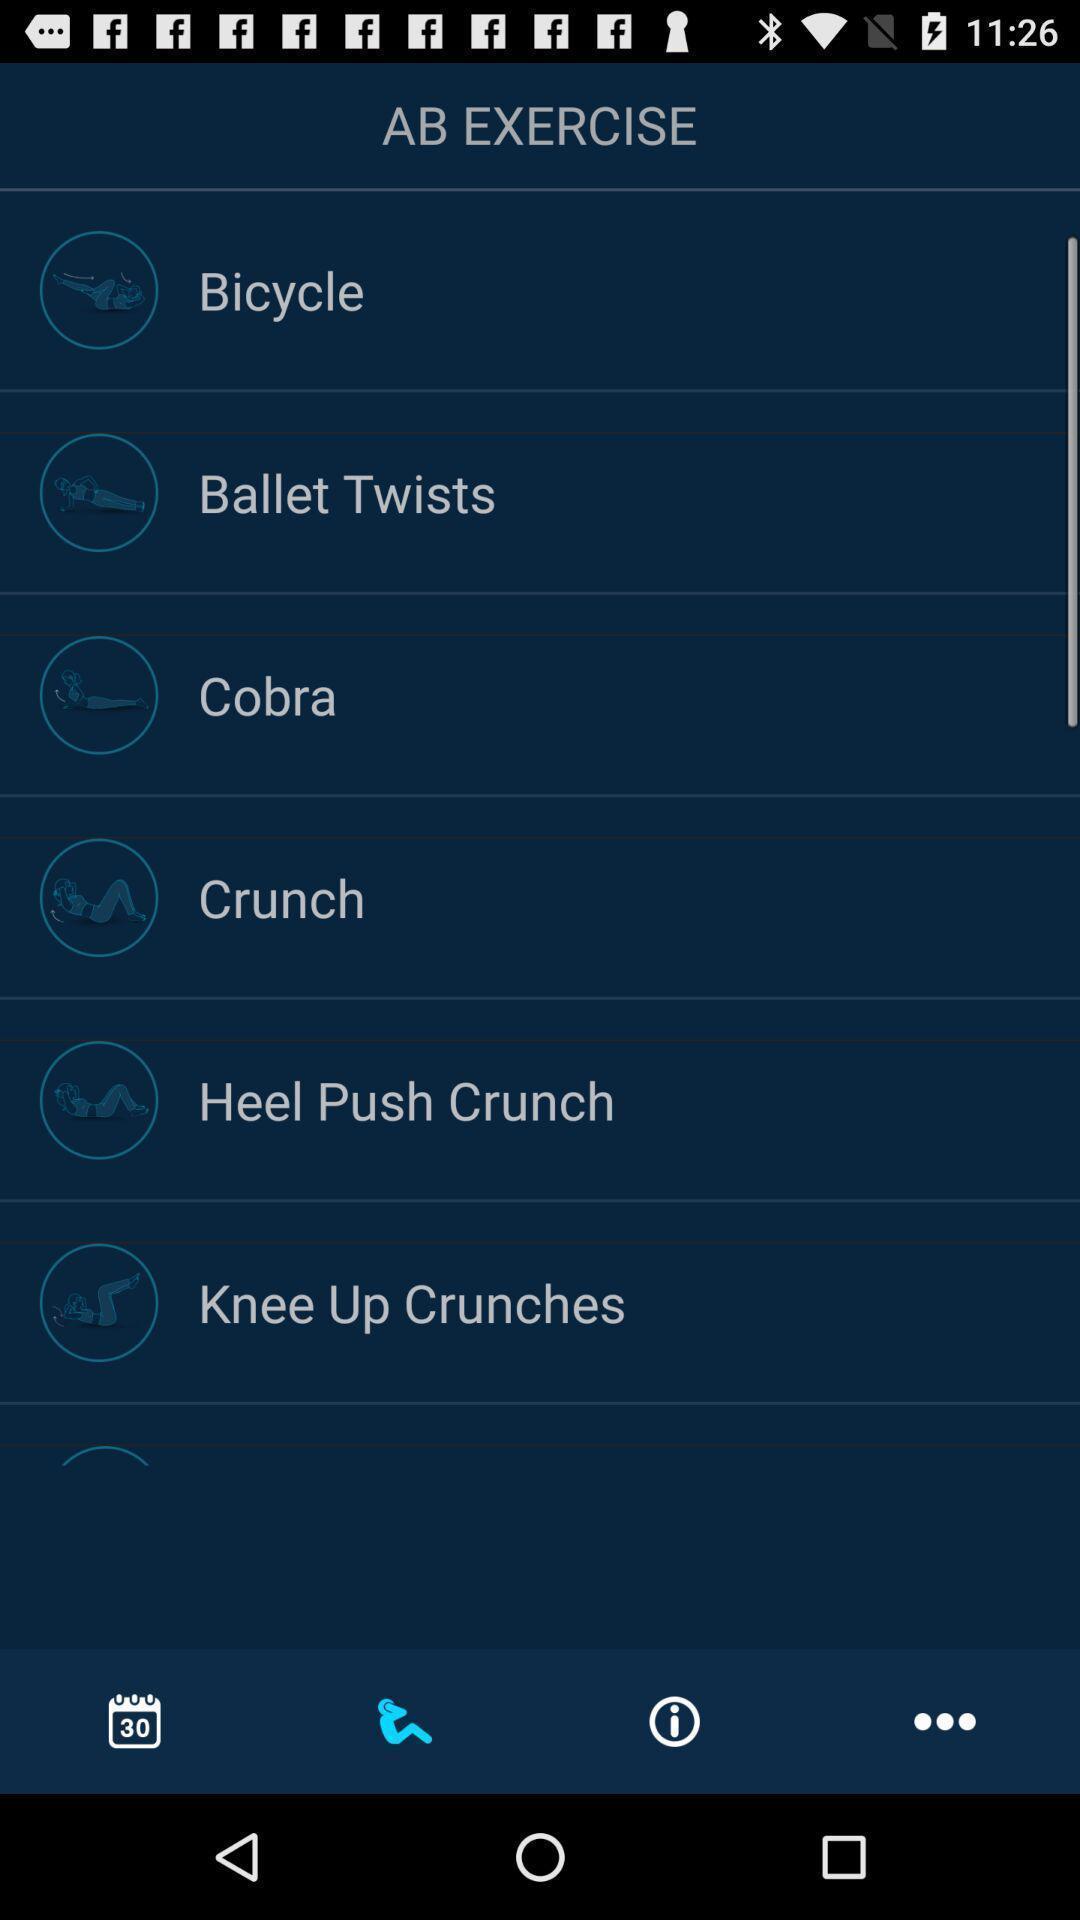What can you discern from this picture? Screen shows list of ab exercises. 